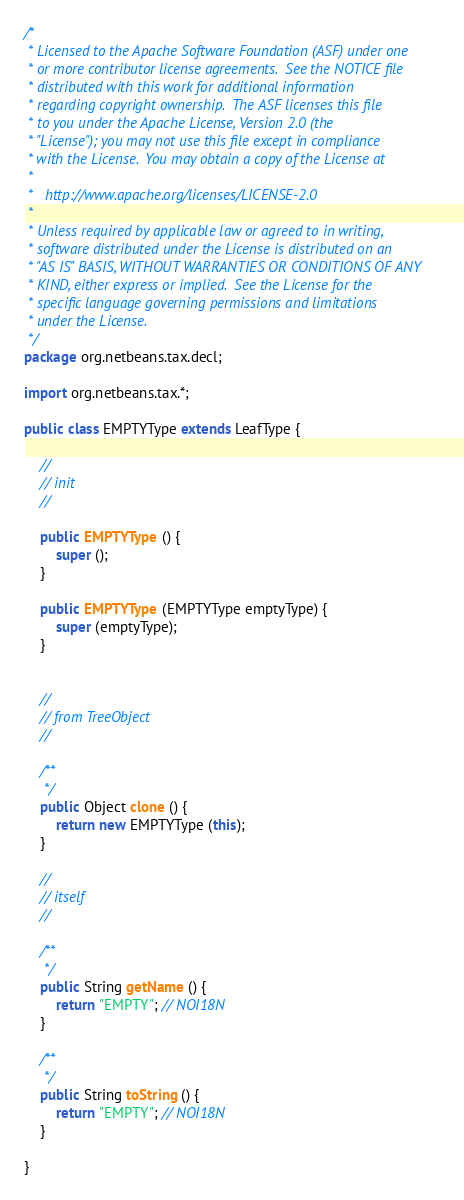Convert code to text. <code><loc_0><loc_0><loc_500><loc_500><_Java_>/*
 * Licensed to the Apache Software Foundation (ASF) under one
 * or more contributor license agreements.  See the NOTICE file
 * distributed with this work for additional information
 * regarding copyright ownership.  The ASF licenses this file
 * to you under the Apache License, Version 2.0 (the
 * "License"); you may not use this file except in compliance
 * with the License.  You may obtain a copy of the License at
 *
 *   http://www.apache.org/licenses/LICENSE-2.0
 *
 * Unless required by applicable law or agreed to in writing,
 * software distributed under the License is distributed on an
 * "AS IS" BASIS, WITHOUT WARRANTIES OR CONDITIONS OF ANY
 * KIND, either express or implied.  See the License for the
 * specific language governing permissions and limitations
 * under the License.
 */
package org.netbeans.tax.decl;

import org.netbeans.tax.*;

public class EMPTYType extends LeafType {

    //
    // init
    //

    public EMPTYType () {
        super ();
    }

    public EMPTYType (EMPTYType emptyType) {
        super (emptyType);
    }


    //
    // from TreeObject
    //

    /**
     */
    public Object clone () {
        return new EMPTYType (this);
    }

    //
    // itself
    //

    /**
     */
    public String getName () {
        return "EMPTY"; // NOI18N
    }
    
    /**
     */
    public String toString () {
        return "EMPTY"; // NOI18N
    }
    
}
</code> 